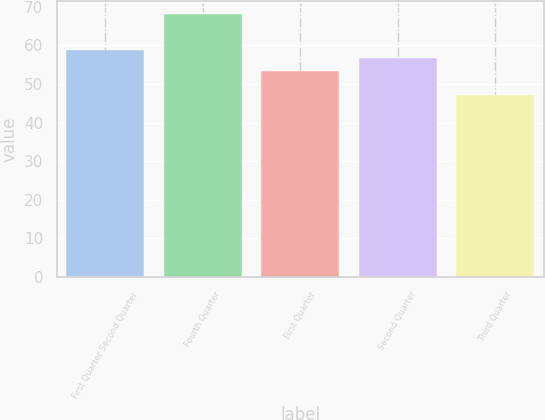Convert chart to OTSL. <chart><loc_0><loc_0><loc_500><loc_500><bar_chart><fcel>First Quarter Second Quarter<fcel>Fourth Quarter<fcel>First Quarter<fcel>Second Quarter<fcel>Third Quarter<nl><fcel>58.77<fcel>68.07<fcel>53.33<fcel>56.68<fcel>47.12<nl></chart> 